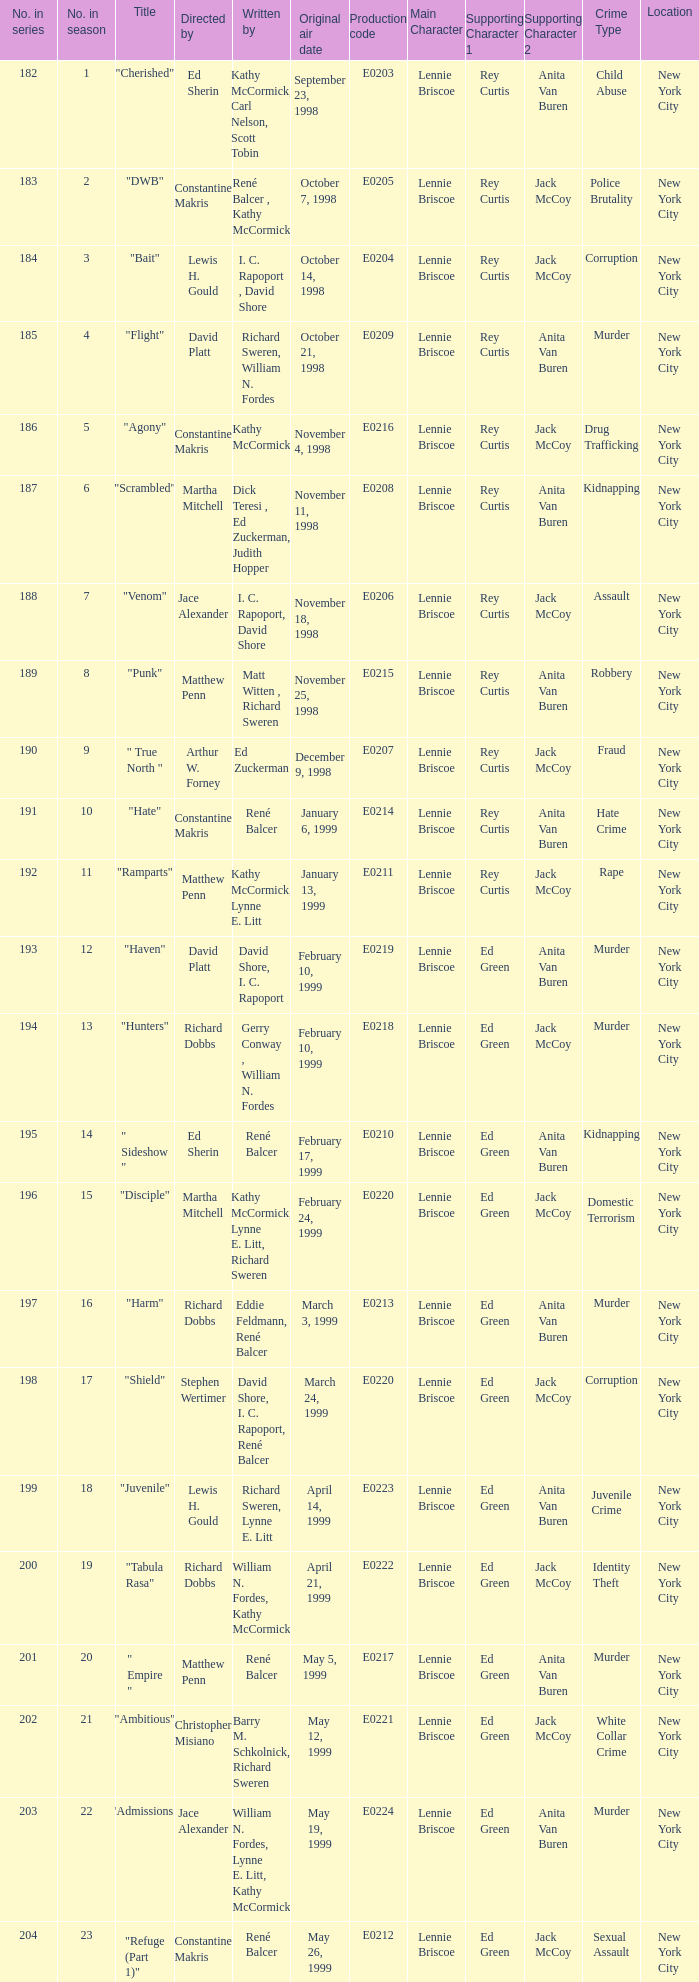Help me parse the entirety of this table. {'header': ['No. in series', 'No. in season', 'Title', 'Directed by', 'Written by', 'Original air date', 'Production code', 'Main Character', 'Supporting Character 1', 'Supporting Character 2', 'Crime Type', 'Location'], 'rows': [['182', '1', '"Cherished"', 'Ed Sherin', 'Kathy McCormick, Carl Nelson, Scott Tobin', 'September 23, 1998', 'E0203', 'Lennie Briscoe', 'Rey Curtis', 'Anita Van Buren', 'Child Abuse', 'New York City'], ['183', '2', '"DWB"', 'Constantine Makris', 'René Balcer , Kathy McCormick', 'October 7, 1998', 'E0205', 'Lennie Briscoe', 'Rey Curtis', 'Jack McCoy', 'Police Brutality', 'New York City'], ['184', '3', '"Bait"', 'Lewis H. Gould', 'I. C. Rapoport , David Shore', 'October 14, 1998', 'E0204', 'Lennie Briscoe', 'Rey Curtis', 'Jack McCoy', 'Corruption', 'New York City'], ['185', '4', '"Flight"', 'David Platt', 'Richard Sweren, William N. Fordes', 'October 21, 1998', 'E0209', 'Lennie Briscoe', 'Rey Curtis', 'Anita Van Buren', 'Murder', 'New York City'], ['186', '5', '"Agony"', 'Constantine Makris', 'Kathy McCormick', 'November 4, 1998', 'E0216', 'Lennie Briscoe', 'Rey Curtis', 'Jack McCoy', 'Drug Trafficking', 'New York City'], ['187', '6', '"Scrambled"', 'Martha Mitchell', 'Dick Teresi , Ed Zuckerman, Judith Hopper', 'November 11, 1998', 'E0208', 'Lennie Briscoe', 'Rey Curtis', 'Anita Van Buren', 'Kidnapping', 'New York City'], ['188', '7', '"Venom"', 'Jace Alexander', 'I. C. Rapoport, David Shore', 'November 18, 1998', 'E0206', 'Lennie Briscoe', 'Rey Curtis', 'Jack McCoy', 'Assault', 'New York City'], ['189', '8', '"Punk"', 'Matthew Penn', 'Matt Witten , Richard Sweren', 'November 25, 1998', 'E0215', 'Lennie Briscoe', 'Rey Curtis', 'Anita Van Buren', 'Robbery', 'New York City'], ['190', '9', '" True North "', 'Arthur W. Forney', 'Ed Zuckerman', 'December 9, 1998', 'E0207', 'Lennie Briscoe', 'Rey Curtis', 'Jack McCoy', 'Fraud', 'New York City'], ['191', '10', '"Hate"', 'Constantine Makris', 'René Balcer', 'January 6, 1999', 'E0214', 'Lennie Briscoe', 'Rey Curtis', 'Anita Van Buren', 'Hate Crime', 'New York City'], ['192', '11', '"Ramparts"', 'Matthew Penn', 'Kathy McCormick, Lynne E. Litt', 'January 13, 1999', 'E0211', 'Lennie Briscoe', 'Rey Curtis', 'Jack McCoy', 'Rape', 'New York City'], ['193', '12', '"Haven"', 'David Platt', 'David Shore, I. C. Rapoport', 'February 10, 1999', 'E0219', 'Lennie Briscoe', 'Ed Green', 'Anita Van Buren', 'Murder', 'New York City'], ['194', '13', '"Hunters"', 'Richard Dobbs', 'Gerry Conway , William N. Fordes', 'February 10, 1999', 'E0218', 'Lennie Briscoe', 'Ed Green', 'Jack McCoy', 'Murder', 'New York City'], ['195', '14', '" Sideshow "', 'Ed Sherin', 'René Balcer', 'February 17, 1999', 'E0210', 'Lennie Briscoe', 'Ed Green', 'Anita Van Buren', 'Kidnapping', 'New York City'], ['196', '15', '"Disciple"', 'Martha Mitchell', 'Kathy McCormick, Lynne E. Litt, Richard Sweren', 'February 24, 1999', 'E0220', 'Lennie Briscoe', 'Ed Green', 'Jack McCoy', 'Domestic Terrorism', 'New York City'], ['197', '16', '"Harm"', 'Richard Dobbs', 'Eddie Feldmann, René Balcer', 'March 3, 1999', 'E0213', 'Lennie Briscoe', 'Ed Green', 'Anita Van Buren', 'Murder', 'New York City'], ['198', '17', '"Shield"', 'Stephen Wertimer', 'David Shore, I. C. Rapoport, René Balcer', 'March 24, 1999', 'E0220', 'Lennie Briscoe', 'Ed Green', 'Jack McCoy', 'Corruption', 'New York City'], ['199', '18', '"Juvenile"', 'Lewis H. Gould', 'Richard Sweren, Lynne E. Litt', 'April 14, 1999', 'E0223', 'Lennie Briscoe', 'Ed Green', 'Anita Van Buren', 'Juvenile Crime', 'New York City'], ['200', '19', '"Tabula Rasa"', 'Richard Dobbs', 'William N. Fordes, Kathy McCormick', 'April 21, 1999', 'E0222', 'Lennie Briscoe', 'Ed Green', 'Jack McCoy', 'Identity Theft', 'New York City'], ['201', '20', '" Empire "', 'Matthew Penn', 'René Balcer', 'May 5, 1999', 'E0217', 'Lennie Briscoe', 'Ed Green', 'Anita Van Buren', 'Murder', 'New York City'], ['202', '21', '"Ambitious"', 'Christopher Misiano', 'Barry M. Schkolnick, Richard Sweren', 'May 12, 1999', 'E0221', 'Lennie Briscoe', 'Ed Green', 'Jack McCoy', 'White Collar Crime', 'New York City'], ['203', '22', '"Admissions"', 'Jace Alexander', 'William N. Fordes, Lynne E. Litt, Kathy McCormick', 'May 19, 1999', 'E0224', 'Lennie Briscoe', 'Ed Green', 'Anita Van Buren', 'Murder', 'New York City'], ['204', '23', '"Refuge (Part 1)"', 'Constantine Makris', 'René Balcer', 'May 26, 1999', 'E0212', 'Lennie Briscoe', 'Ed Green', 'Jack McCoy', 'Sexual Assault', 'New York City']]} The episode with the original air date January 6, 1999, has what production code? E0214. 